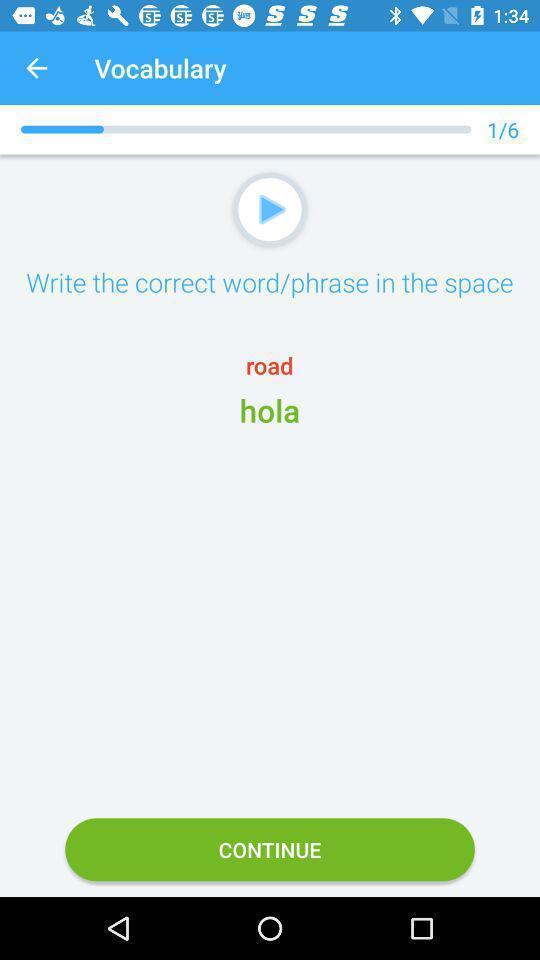Describe the content in this image. Screen shows vocabulary with continue option. 